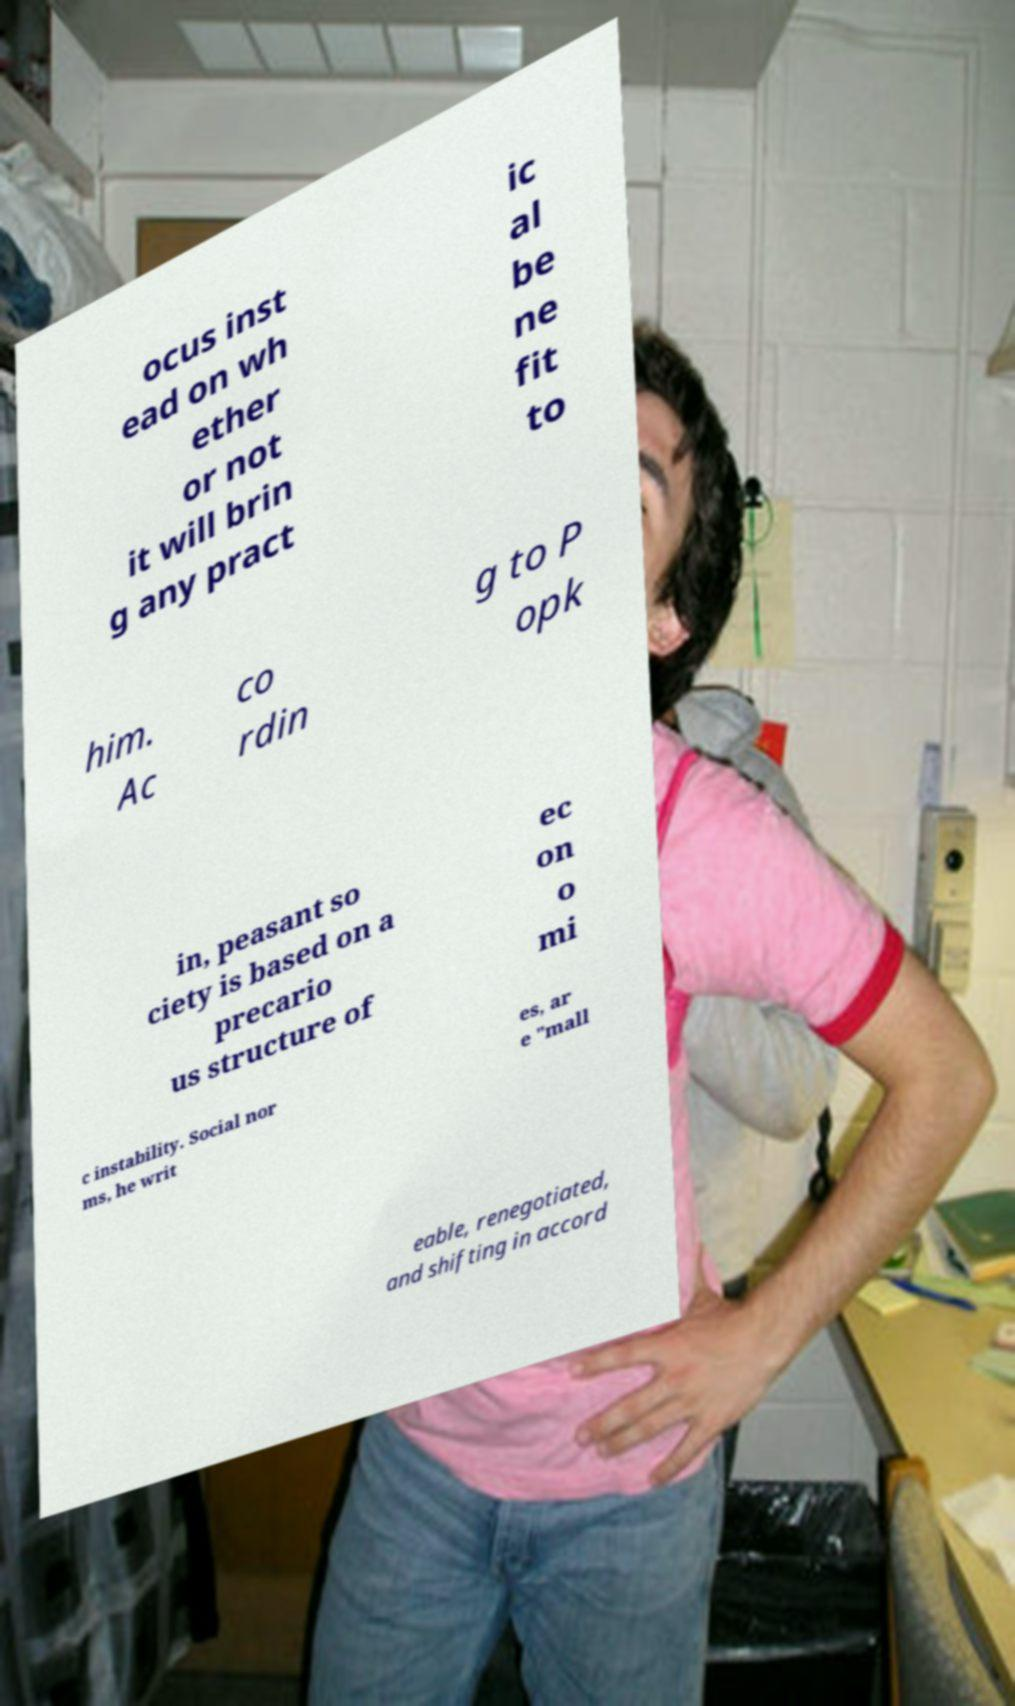Could you assist in decoding the text presented in this image and type it out clearly? ocus inst ead on wh ether or not it will brin g any pract ic al be ne fit to him. Ac co rdin g to P opk in, peasant so ciety is based on a precario us structure of ec on o mi c instability. Social nor ms, he writ es, ar e "mall eable, renegotiated, and shifting in accord 